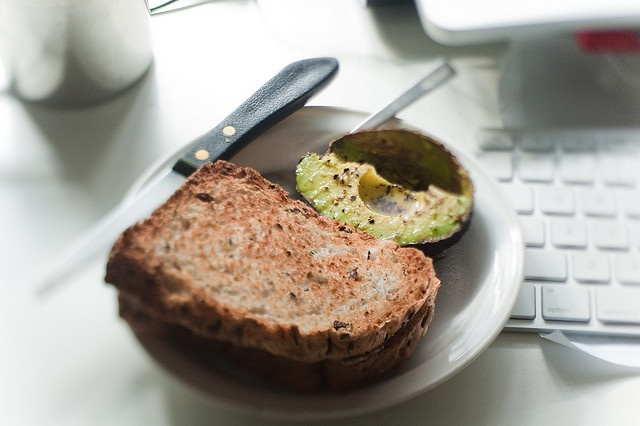Describe the objects in this image and their specific colors. I can see bowl in white, black, tan, gray, and maroon tones, sandwich in white, black, tan, and maroon tones, keyboard in white, lightgray, darkgray, and gray tones, cup in white, lightgray, darkgray, and gray tones, and knife in white, lightgray, darkgray, black, and gray tones in this image. 